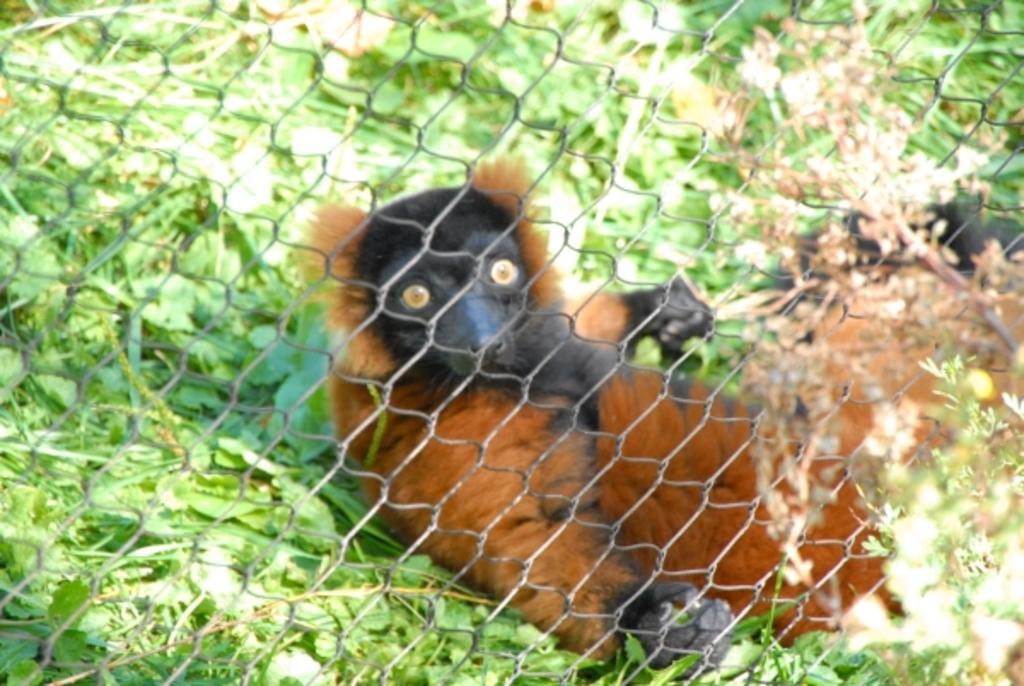Can you describe this image briefly? In the picture i can see some animal which is in brown and black color resting on ground behind fencing, there are some leaves which are in green color. 